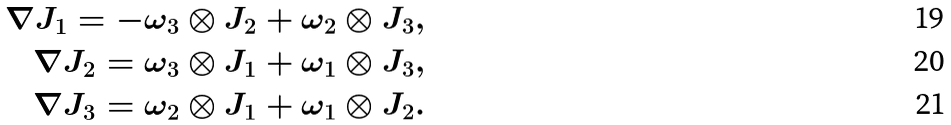<formula> <loc_0><loc_0><loc_500><loc_500>\nabla J _ { 1 } = - \omega _ { 3 } \otimes J _ { 2 } + \omega _ { 2 } \otimes J _ { 3 } , \\ \nabla J _ { 2 } = \omega _ { 3 } \otimes J _ { 1 } + \omega _ { 1 } \otimes J _ { 3 } , \\ \nabla J _ { 3 } = \omega _ { 2 } \otimes J _ { 1 } + \omega _ { 1 } \otimes J _ { 2 } .</formula> 